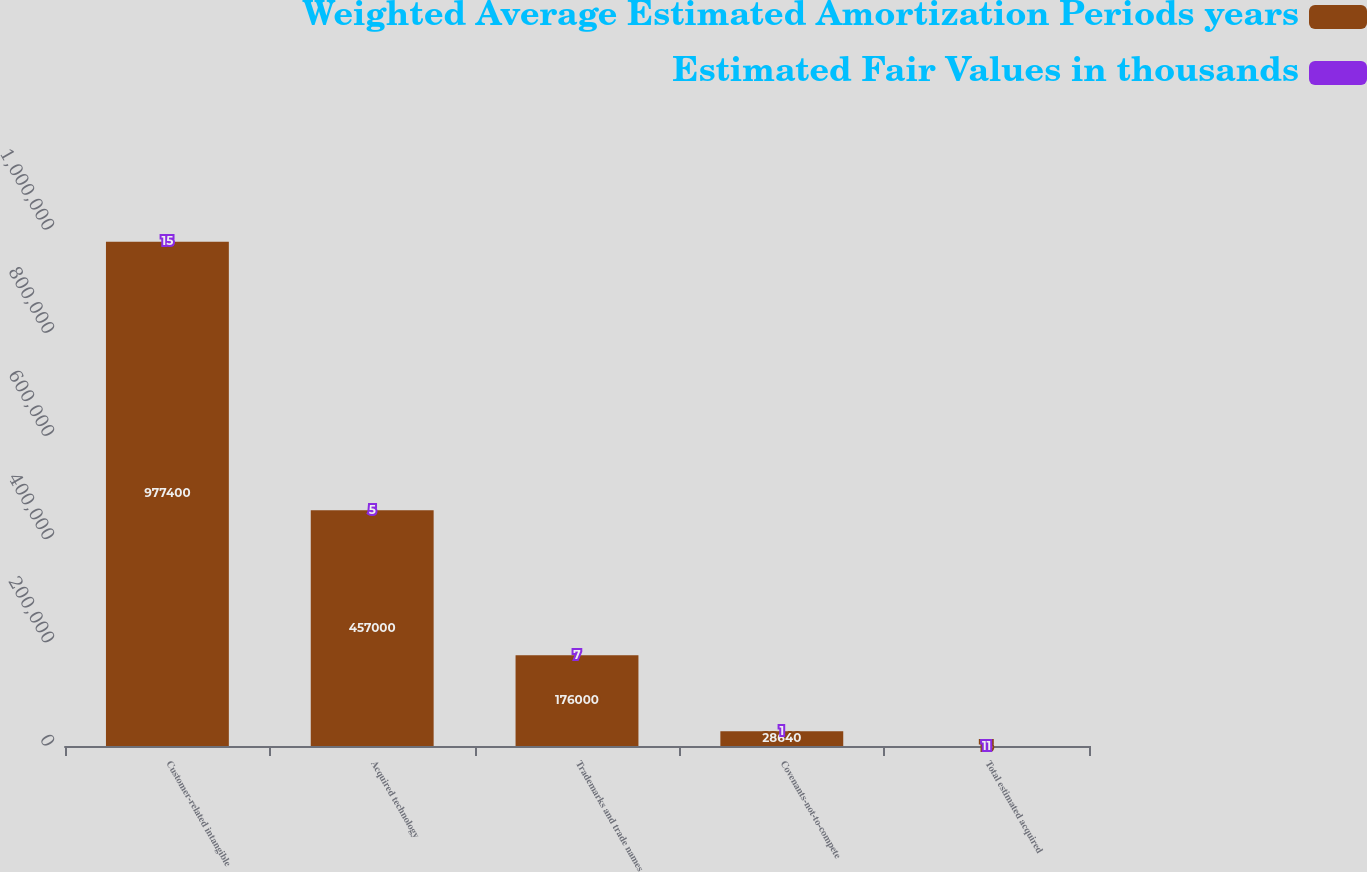<chart> <loc_0><loc_0><loc_500><loc_500><stacked_bar_chart><ecel><fcel>Customer-related intangible<fcel>Acquired technology<fcel>Trademarks and trade names<fcel>Covenants-not-to-compete<fcel>Total estimated acquired<nl><fcel>Weighted Average Estimated Amortization Periods years<fcel>977400<fcel>457000<fcel>176000<fcel>28640<fcel>15<nl><fcel>Estimated Fair Values in thousands<fcel>15<fcel>5<fcel>7<fcel>1<fcel>11<nl></chart> 